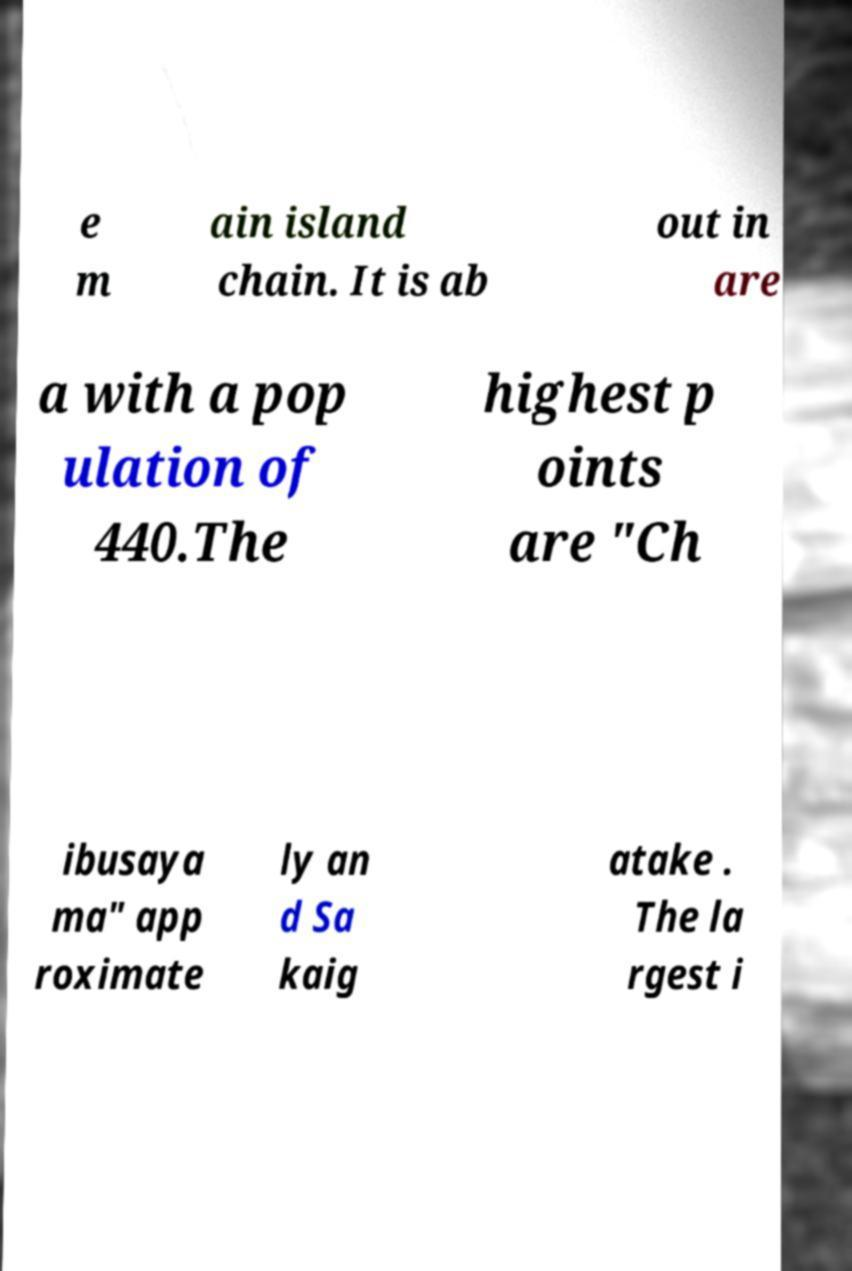What messages or text are displayed in this image? I need them in a readable, typed format. e m ain island chain. It is ab out in are a with a pop ulation of 440.The highest p oints are "Ch ibusaya ma" app roximate ly an d Sa kaig atake . The la rgest i 